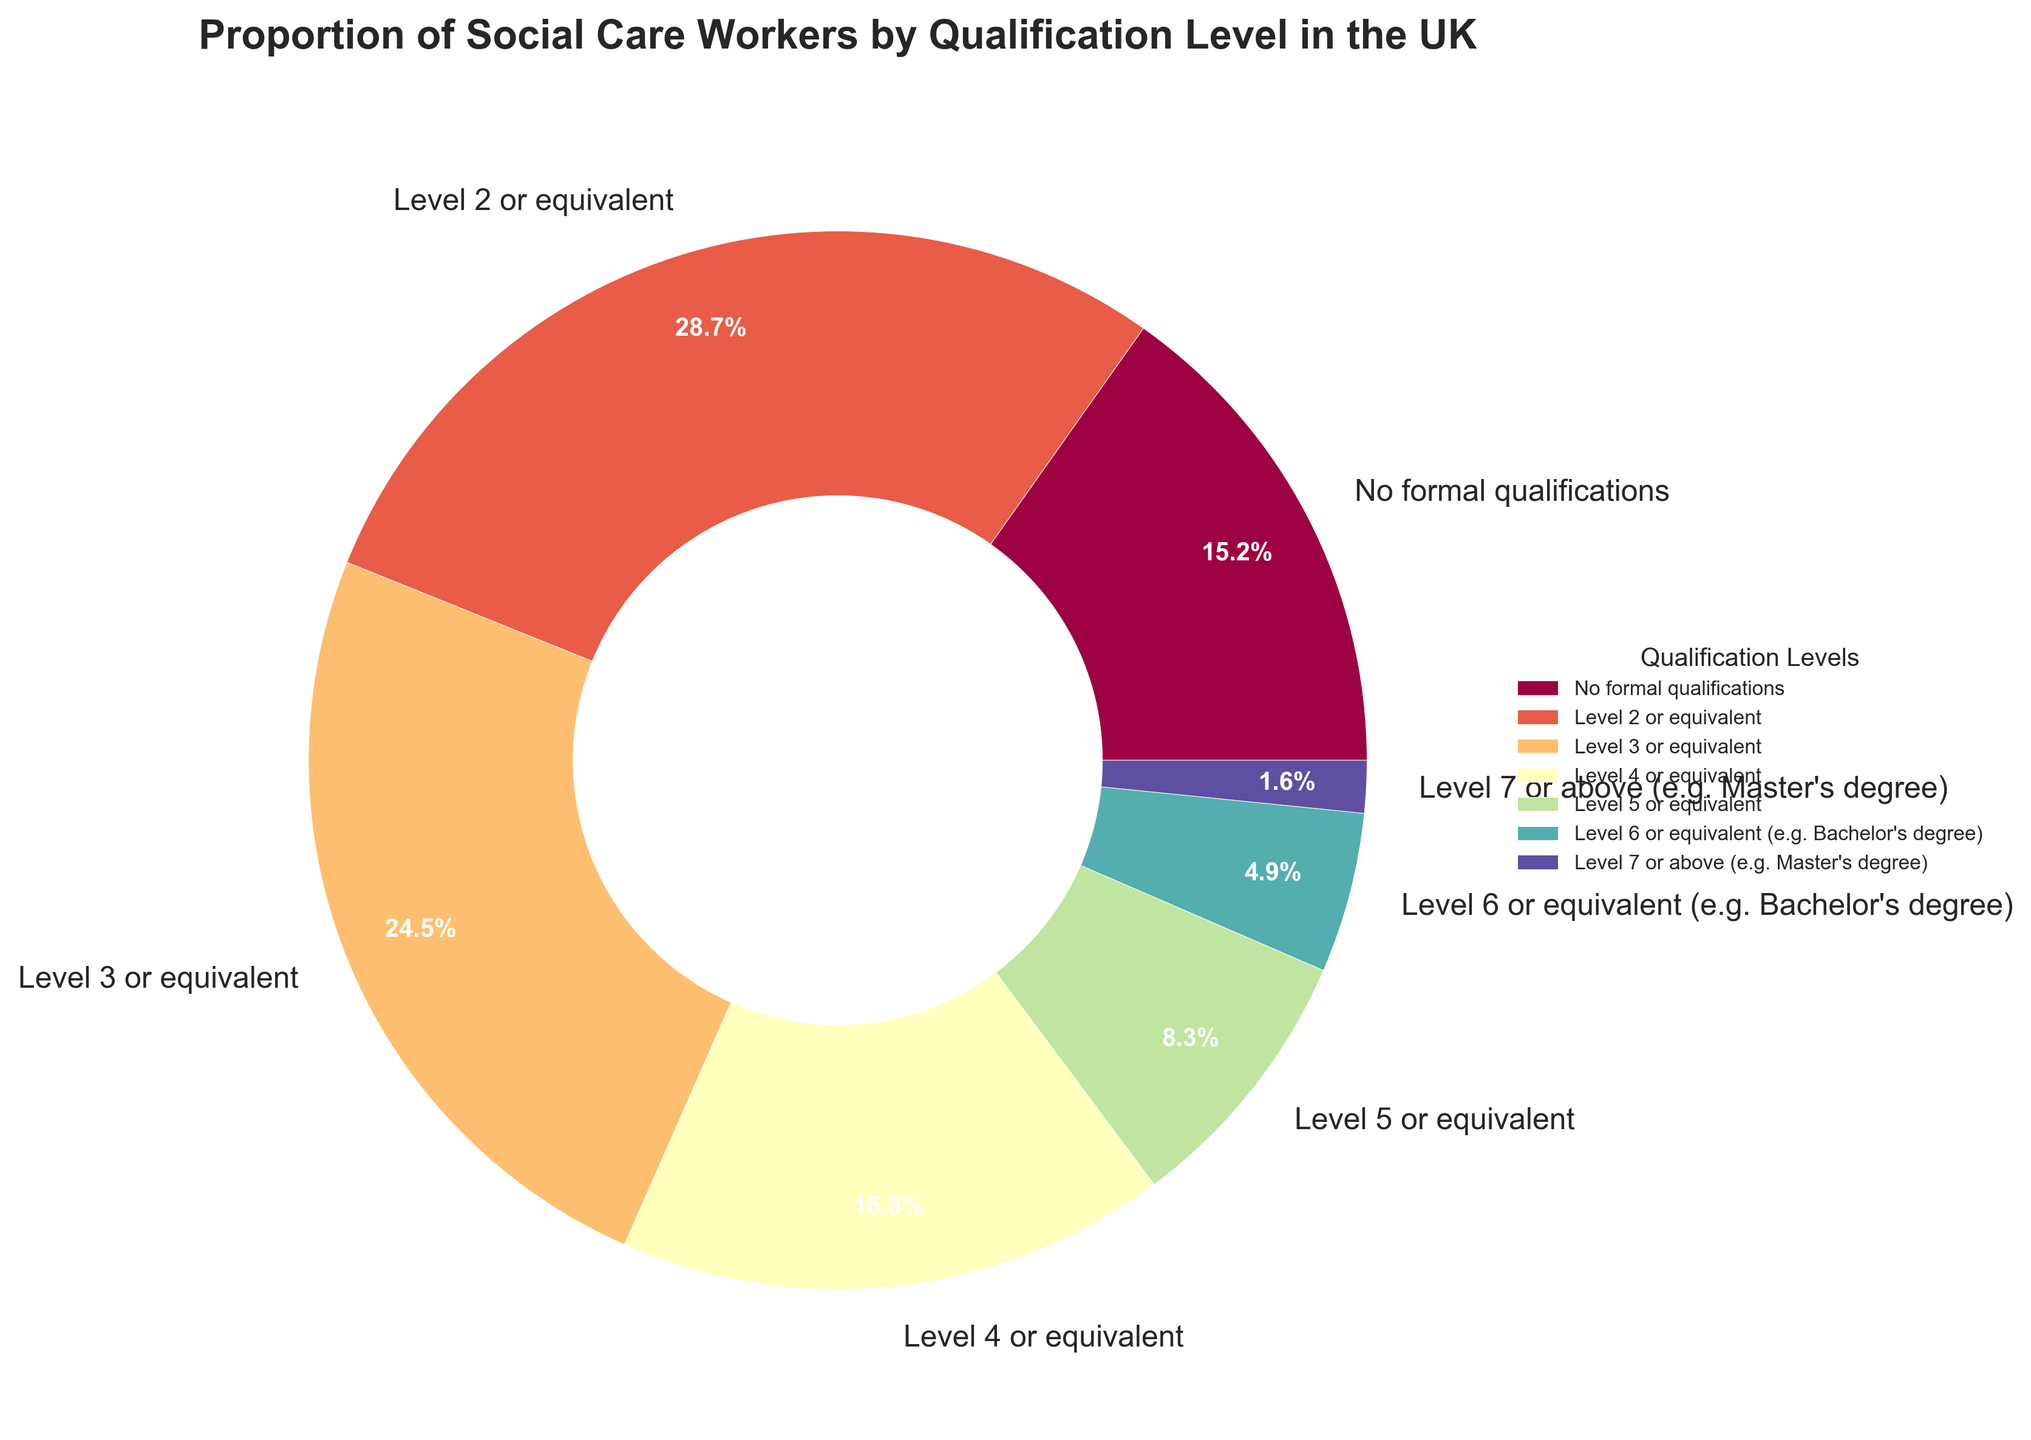Which qualification level has the highest proportion of social care workers? Identify the label with the largest percentage on the pie chart. The "Level 2 or equivalent" slice is the largest, marked with 28.7%.
Answer: Level 2 or equivalent What is the combined percentage of social care workers with Level 5 or higher qualifications? Sum the percentages of Level 5, Level 6, and Level 7 or above qualifications. 8.3% + 4.9% + 1.6% = 14.8%.
Answer: 14.8% Is the proportion of workers with no formal qualifications greater than those with a Level 4 or equivalent qualification? Compare the percentages for "No formal qualifications" (15.2%) and "Level 4 or equivalent" (16.8%). The percentage for Level 4 or equivalent is greater.
Answer: No What is the median qualification level based on the proportions observed? Order the percentages from lowest to highest, then find the middle value. Ordered: 1.6%, 4.9%, 8.3%, 15.2%, 16.8%, 24.5%, 28.7%. The middle value is 16.8%, corresponding to "Level 4 or equivalent".
Answer: Level 4 or equivalent How much greater is the proportion of social care workers with Level 2 or equivalent compared to Level 3 or equivalent? Subtract the percentage of Level 3 or equivalent from Level 2 or equivalent. 28.7% - 24.5% = 4.2%.
Answer: 4.2% What proportion of social care workers have qualifications at Level 3 or below? Sum the percentages of "No formal qualifications," "Level 2 or equivalent," and "Level 3 or equivalent." 15.2% + 28.7% + 24.5% = 68.4%.
Answer: 68.4% Which qualification level has the smallest proportion of social care workers? Find the smallest percentage on the pie chart. "Level 7 or above (e.g. Master's degree)" has the smallest proportion at 1.6%.
Answer: Level 7 or above How many qualification levels have a proportion greater than 20%? Identify and count the qualification levels with percentages greater than 20%. They are "Level 2 or equivalent" and "Level 3 or equivalent". There are 2 such qualification levels.
Answer: 2 Is the total proportion of workers with Level 4 or higher qualifications greater than the proportion of those with no formal qualifications? Sum the percentages for Level 4, Level 5, Level 6, and Level 7 or above, and compare it to the percentage of those with no formal qualifications. 16.8% + 8.3% + 4.9% + 1.6% = 31.6%, which is greater than 15.2%.
Answer: Yes 